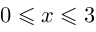Convert formula to latex. <formula><loc_0><loc_0><loc_500><loc_500>0 \leqslant x \leqslant 3</formula> 